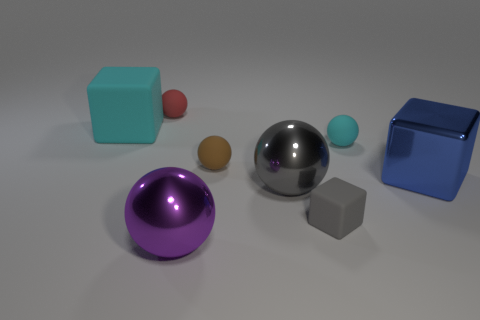Does the small object in front of the big blue thing have the same shape as the big thing behind the blue metal block? Indeed, the small object in front of the big blue cube—apparently a smaller cube— shares the same geometric shape of a cube with the larger object situated behind the large blue metal block. 